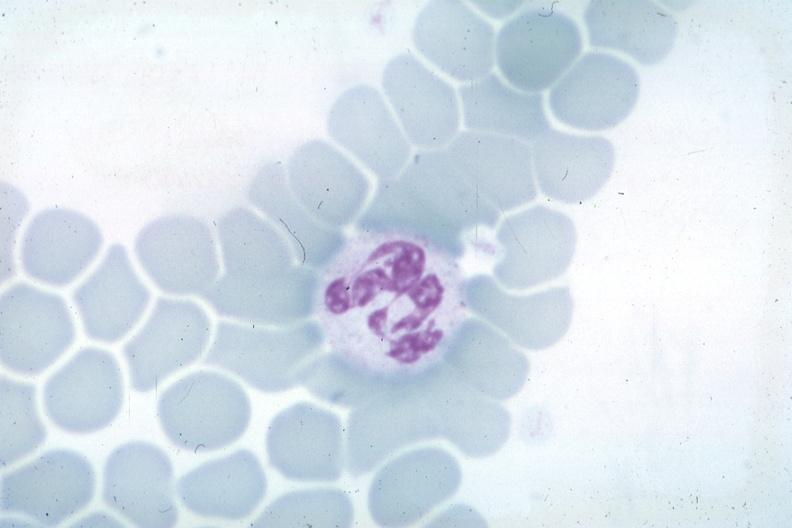s hematologic present?
Answer the question using a single word or phrase. Yes 